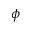<formula> <loc_0><loc_0><loc_500><loc_500>\phi</formula> 